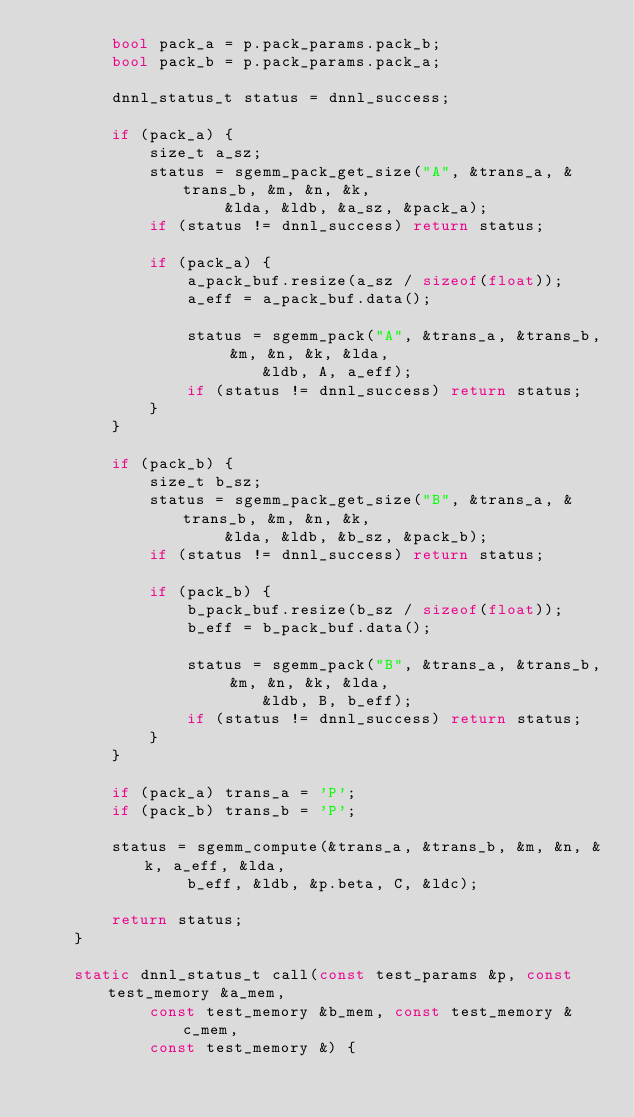<code> <loc_0><loc_0><loc_500><loc_500><_C++_>        bool pack_a = p.pack_params.pack_b;
        bool pack_b = p.pack_params.pack_a;

        dnnl_status_t status = dnnl_success;

        if (pack_a) {
            size_t a_sz;
            status = sgemm_pack_get_size("A", &trans_a, &trans_b, &m, &n, &k,
                    &lda, &ldb, &a_sz, &pack_a);
            if (status != dnnl_success) return status;

            if (pack_a) {
                a_pack_buf.resize(a_sz / sizeof(float));
                a_eff = a_pack_buf.data();

                status = sgemm_pack("A", &trans_a, &trans_b, &m, &n, &k, &lda,
                        &ldb, A, a_eff);
                if (status != dnnl_success) return status;
            }
        }

        if (pack_b) {
            size_t b_sz;
            status = sgemm_pack_get_size("B", &trans_a, &trans_b, &m, &n, &k,
                    &lda, &ldb, &b_sz, &pack_b);
            if (status != dnnl_success) return status;

            if (pack_b) {
                b_pack_buf.resize(b_sz / sizeof(float));
                b_eff = b_pack_buf.data();

                status = sgemm_pack("B", &trans_a, &trans_b, &m, &n, &k, &lda,
                        &ldb, B, b_eff);
                if (status != dnnl_success) return status;
            }
        }

        if (pack_a) trans_a = 'P';
        if (pack_b) trans_b = 'P';

        status = sgemm_compute(&trans_a, &trans_b, &m, &n, &k, a_eff, &lda,
                b_eff, &ldb, &p.beta, C, &ldc);

        return status;
    }

    static dnnl_status_t call(const test_params &p, const test_memory &a_mem,
            const test_memory &b_mem, const test_memory &c_mem,
            const test_memory &) {</code> 